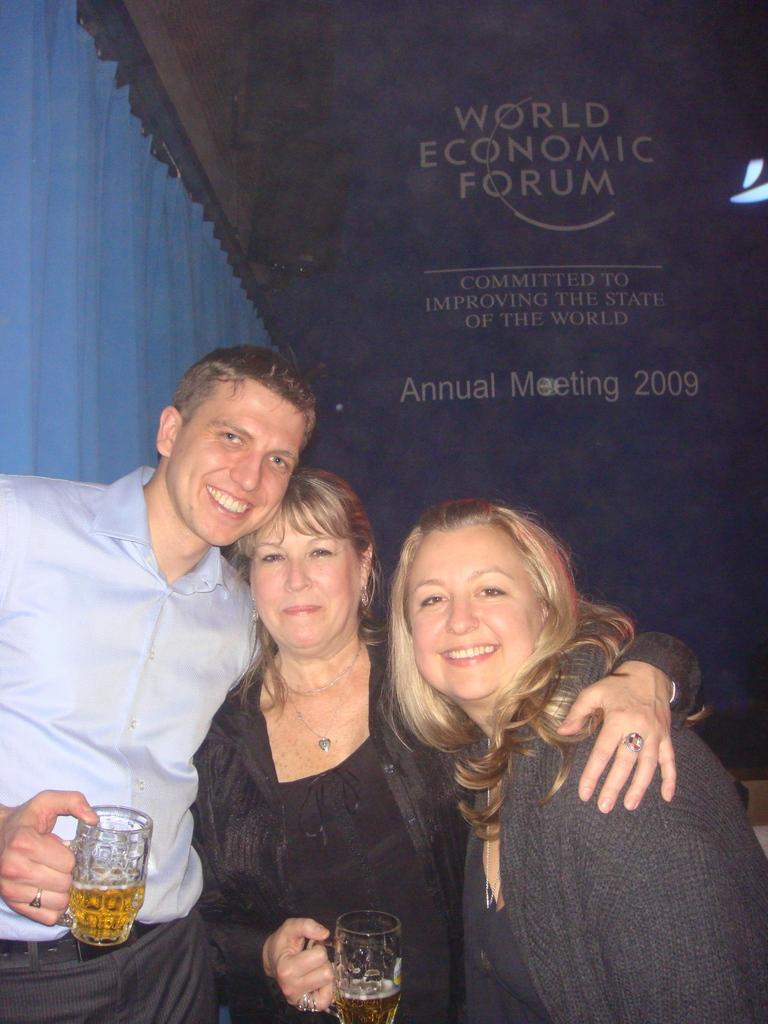How many people are in the image? There are three persons standing in the center of the image. What are the persons holding in their hands? The persons are holding glasses. What is the facial expression of the persons in the image? The persons are smiling. What can be seen in the background of the image? There is a curtain and a wall in the background of the image. What type of apparel is the pig wearing in the image? There is no pig present in the image, so it is not possible to determine what type of apparel it might be wearing. 